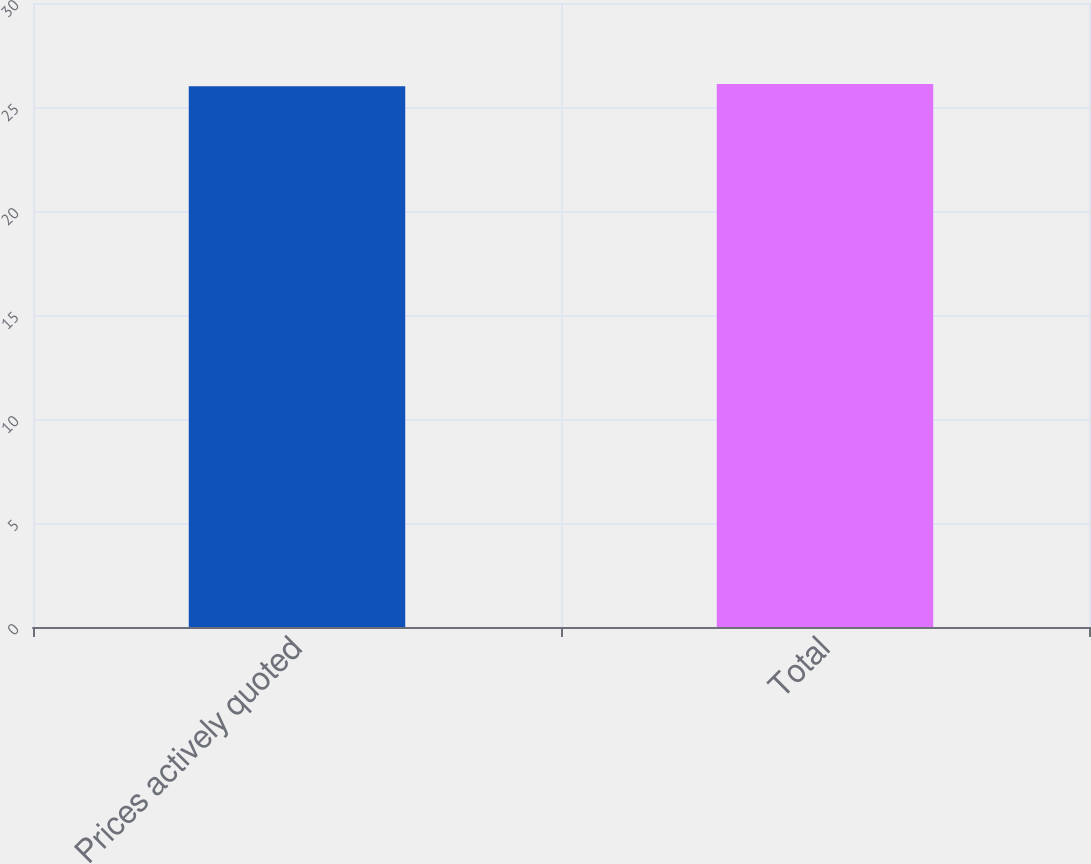Convert chart. <chart><loc_0><loc_0><loc_500><loc_500><bar_chart><fcel>Prices actively quoted<fcel>Total<nl><fcel>26<fcel>26.1<nl></chart> 